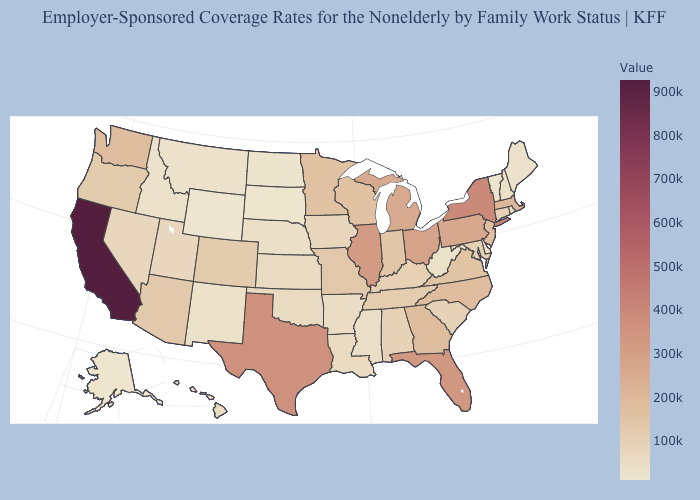Is the legend a continuous bar?
Short answer required. Yes. Among the states that border Kentucky , which have the lowest value?
Keep it brief. West Virginia. Which states have the lowest value in the USA?
Short answer required. Wyoming. Among the states that border Illinois , does Kentucky have the lowest value?
Give a very brief answer. No. Which states have the lowest value in the South?
Write a very short answer. Delaware. Does Michigan have the lowest value in the USA?
Quick response, please. No. Among the states that border New Mexico , which have the highest value?
Give a very brief answer. Texas. 